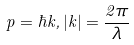<formula> <loc_0><loc_0><loc_500><loc_500>p = \hbar { k } , | k | = \frac { 2 \pi } { \lambda }</formula> 